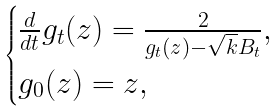Convert formula to latex. <formula><loc_0><loc_0><loc_500><loc_500>\begin{cases} \frac { d } { d t } g _ { t } ( z ) = \frac { 2 } { g _ { t } ( z ) - \sqrt { k } B _ { t } } , \\ g _ { 0 } ( z ) = z , \end{cases}</formula> 